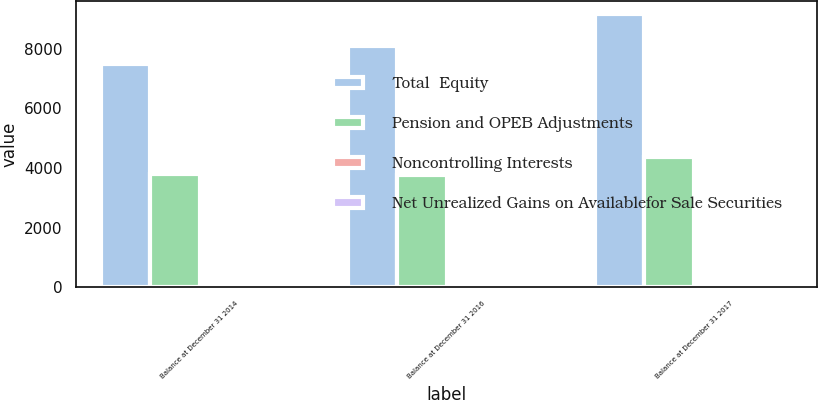Convert chart to OTSL. <chart><loc_0><loc_0><loc_500><loc_500><stacked_bar_chart><ecel><fcel>Balance at December 31 2014<fcel>Balance at December 31 2016<fcel>Balance at December 31 2017<nl><fcel>Total  Equity<fcel>7467<fcel>8094<fcel>9143<nl><fcel>Pension and OPEB Adjustments<fcel>3782<fcel>3764<fcel>4350<nl><fcel>Noncontrolling Interests<fcel>35<fcel>23<fcel>18<nl><fcel>Net Unrealized Gains on Availablefor Sale Securities<fcel>1<fcel>1<fcel>5<nl></chart> 